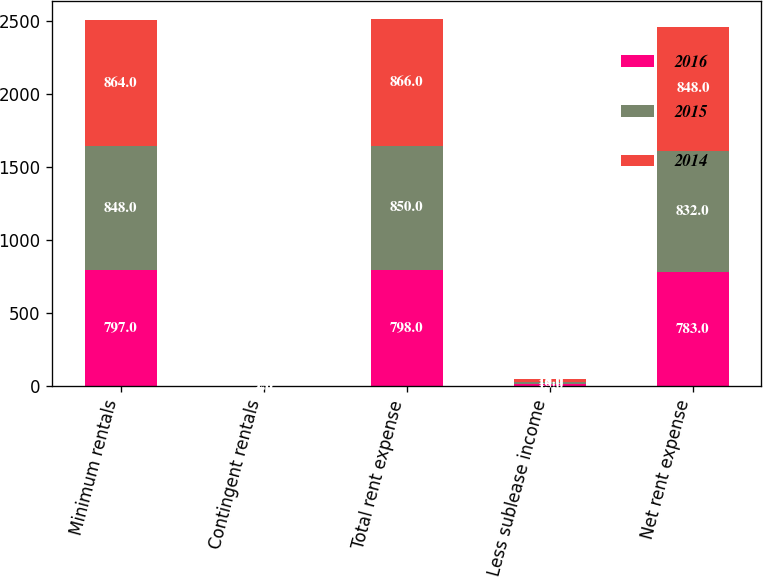<chart> <loc_0><loc_0><loc_500><loc_500><stacked_bar_chart><ecel><fcel>Minimum rentals<fcel>Contingent rentals<fcel>Total rent expense<fcel>Less sublease income<fcel>Net rent expense<nl><fcel>2016<fcel>797<fcel>1<fcel>798<fcel>15<fcel>783<nl><fcel>2015<fcel>848<fcel>2<fcel>850<fcel>18<fcel>832<nl><fcel>2014<fcel>864<fcel>2<fcel>866<fcel>18<fcel>848<nl></chart> 